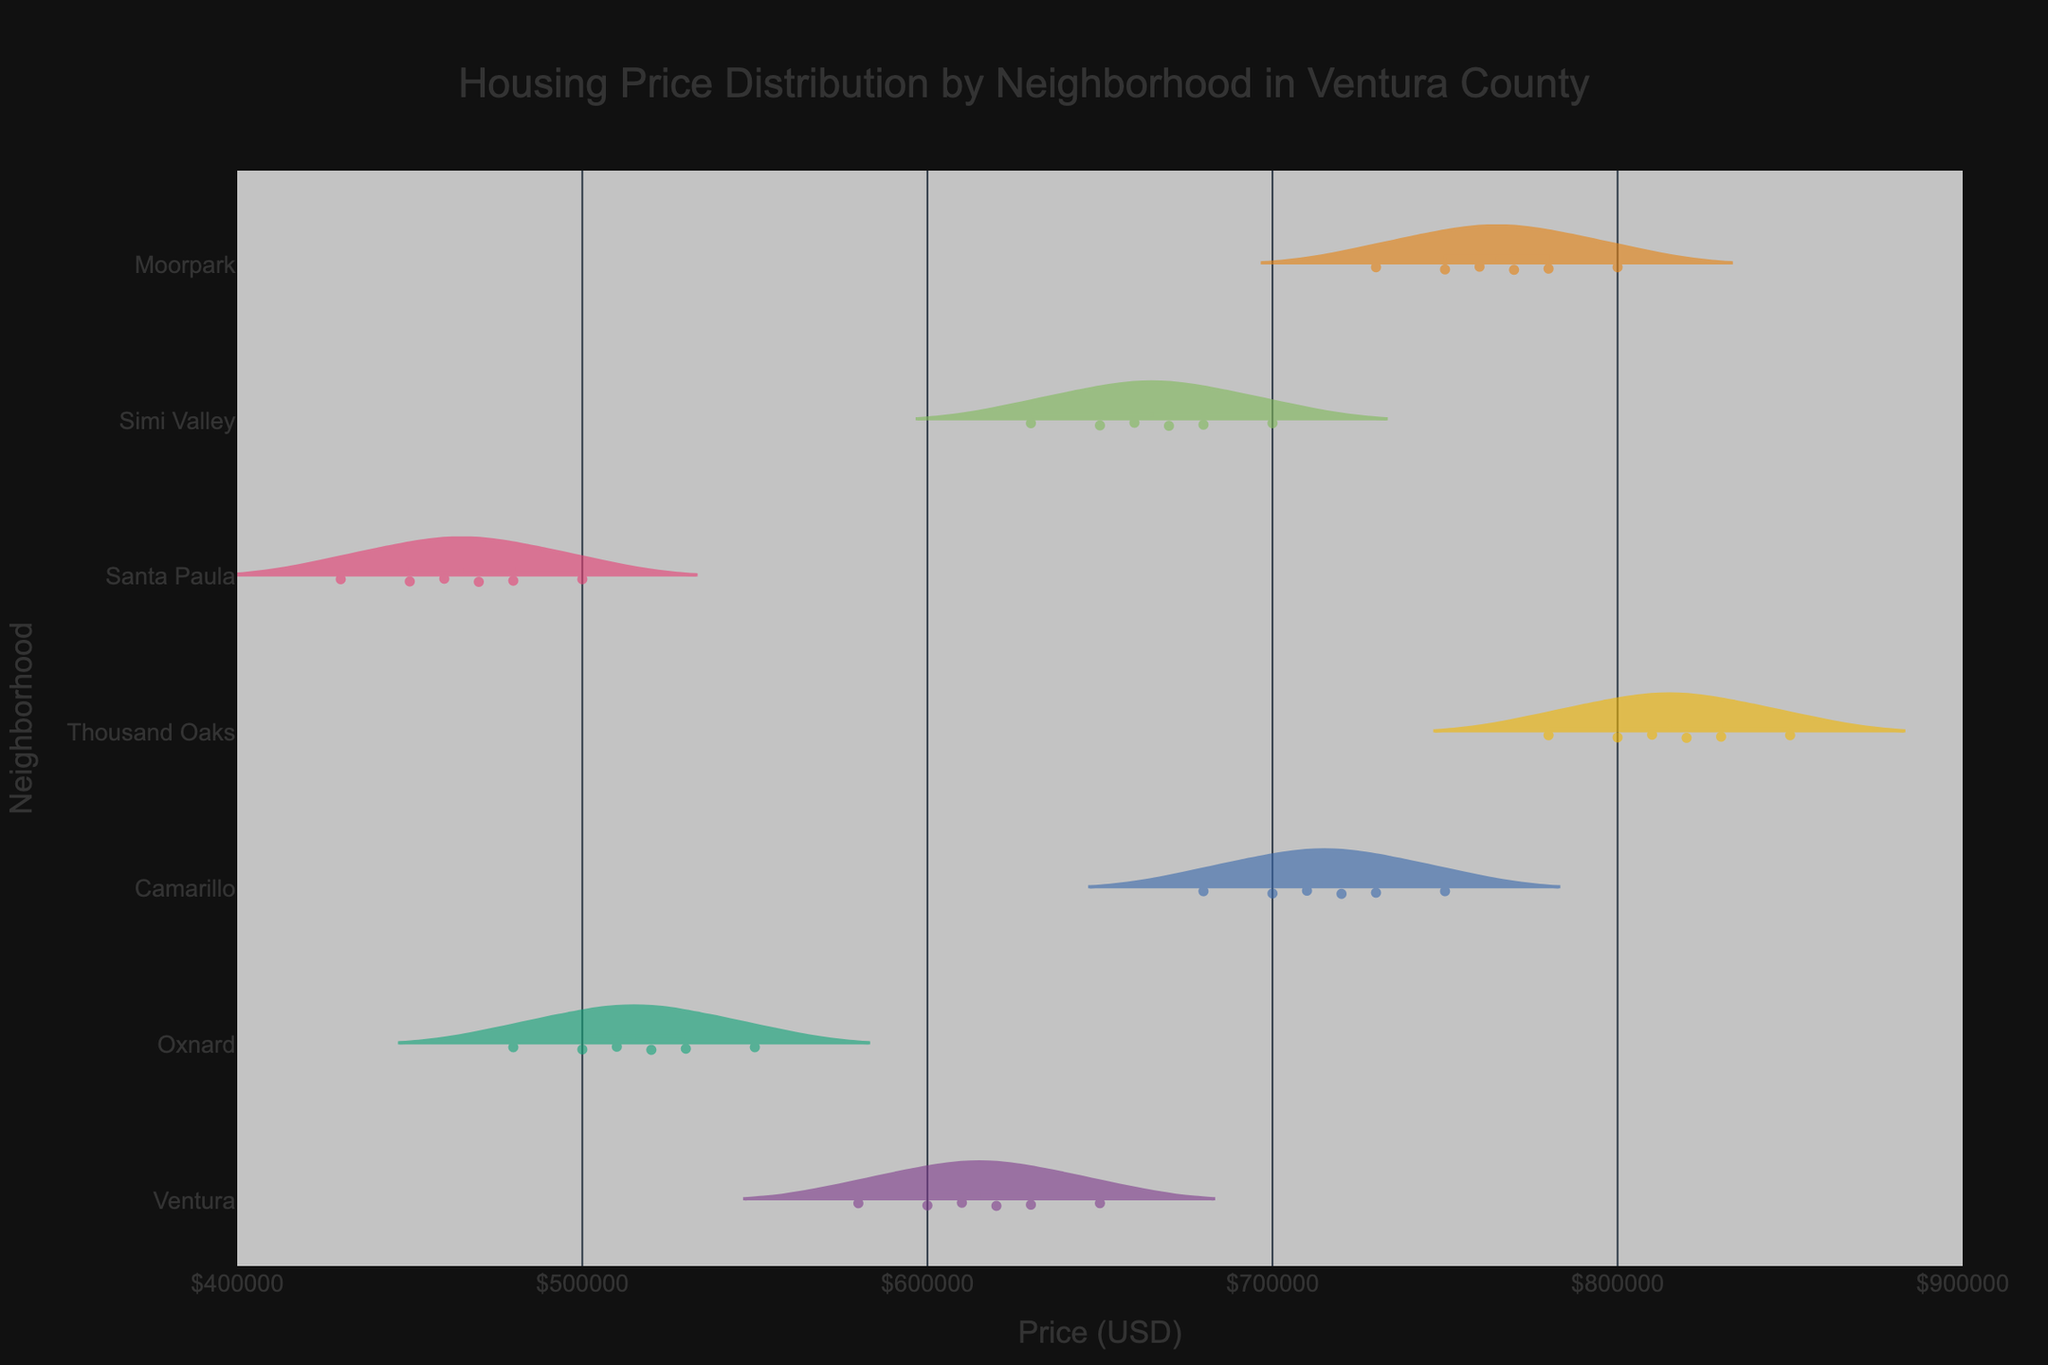What is the title of the figure? The title is displayed prominently above the chart. It provides an overview of what the chart represents.
Answer: Housing Price Distribution by Neighborhood in Ventura County Which neighborhood has the highest mean housing price? To find the neighborhood with the highest mean price, look for the neighborhood where the horizontal line representing the mean is positioned the farthest to the right.
Answer: Thousand Oaks What is the price range for houses in Oxnard? Examine the spread of the violin plot for Oxnard to determine the lowest and highest prices represented.
Answer: $480,000 to $550,000 How do the median prices of houses in Camarillo and Simi Valley compare? Identify the horizontal lines inside the violin plots for both neighborhoods. The median line generally divides the plot into two even halves. Compare their positions along the x-axis.
Answer: Camarillo's median price is higher than Simi Valley's Which neighborhood shows the widest distribution in housing prices? Look for the neighborhood with the largest spread in its violin plot, indicating the widest range of prices.
Answer: Moorpark How does the range of housing prices in Santa Paula compare to that in Ventura? Evaluate the spread of both violin plots by noting the lower and upper bounds. Compare these ranges to see which neighborhood has a wider price distribution.
Answer: Santa Paula's range is narrower than Ventura's What is the typical price for a house in Thousand Oaks, based on the chart? The typical price can be approximated by looking at the mean or median line within the violin plot for Thousand Oaks.
Answer: Around $810,000 Is there overlap in the price ranges of houses between Oxnard and Santa Paula? Compare the boundaries of the violin plots for both Oxnard and Santa Paula to see if their ranges intersect.
Answer: Yes Which neighborhood has the least expensive houses on average? Locate the neighborhood with the mean line positioned the farthest to the left in the chart.
Answer: Santa Paula Are the housing prices in Moorpark generally higher than those in Ventura? Compare the mean positions of both neighborhoods' violin plots. If Moorpark's mean line is situated further right, its prices are generally higher.
Answer: Yes 